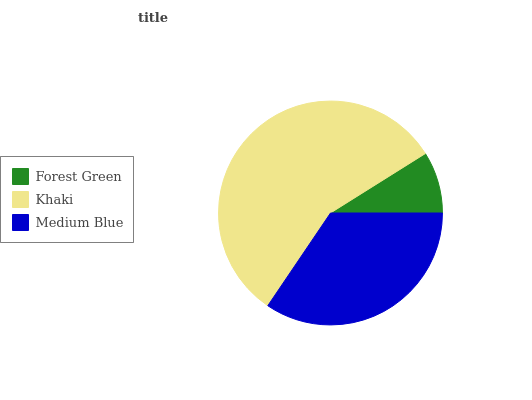Is Forest Green the minimum?
Answer yes or no. Yes. Is Khaki the maximum?
Answer yes or no. Yes. Is Medium Blue the minimum?
Answer yes or no. No. Is Medium Blue the maximum?
Answer yes or no. No. Is Khaki greater than Medium Blue?
Answer yes or no. Yes. Is Medium Blue less than Khaki?
Answer yes or no. Yes. Is Medium Blue greater than Khaki?
Answer yes or no. No. Is Khaki less than Medium Blue?
Answer yes or no. No. Is Medium Blue the high median?
Answer yes or no. Yes. Is Medium Blue the low median?
Answer yes or no. Yes. Is Khaki the high median?
Answer yes or no. No. Is Forest Green the low median?
Answer yes or no. No. 